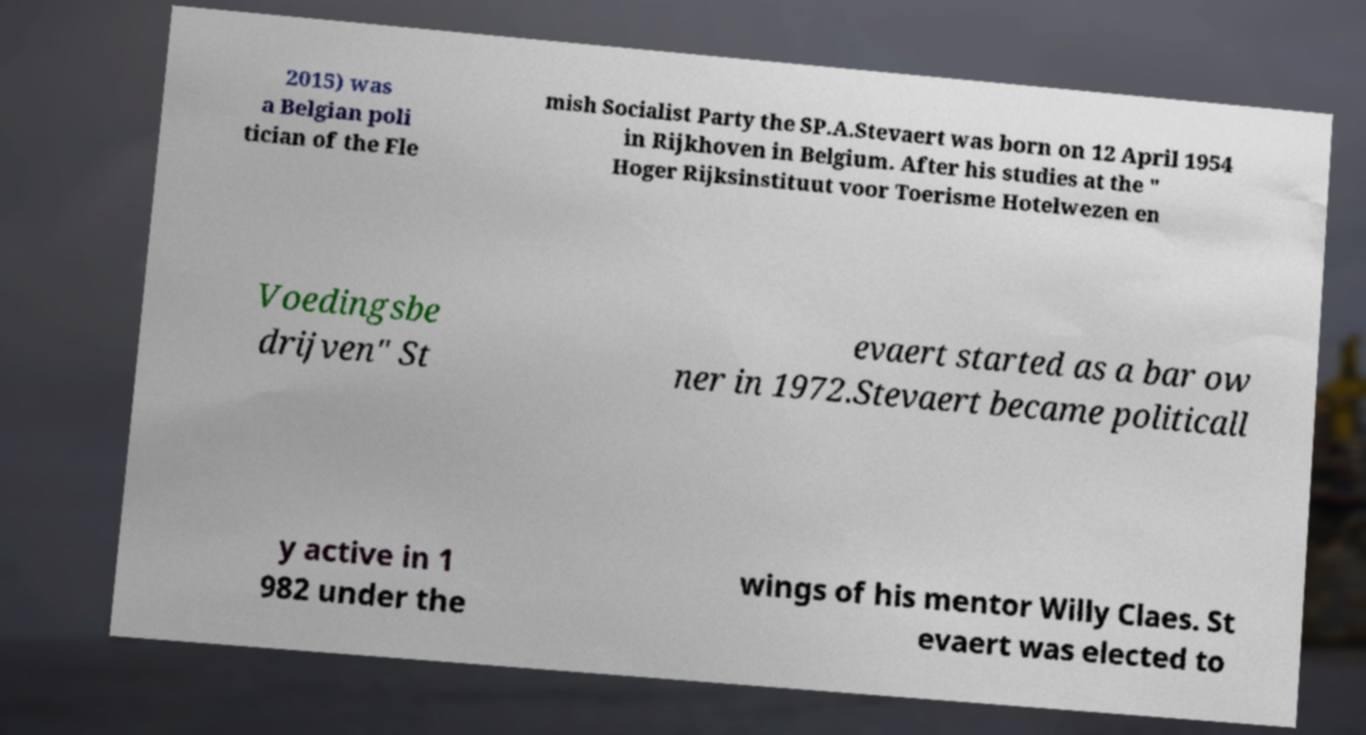There's text embedded in this image that I need extracted. Can you transcribe it verbatim? 2015) was a Belgian poli tician of the Fle mish Socialist Party the SP.A.Stevaert was born on 12 April 1954 in Rijkhoven in Belgium. After his studies at the " Hoger Rijksinstituut voor Toerisme Hotelwezen en Voedingsbe drijven" St evaert started as a bar ow ner in 1972.Stevaert became politicall y active in 1 982 under the wings of his mentor Willy Claes. St evaert was elected to 